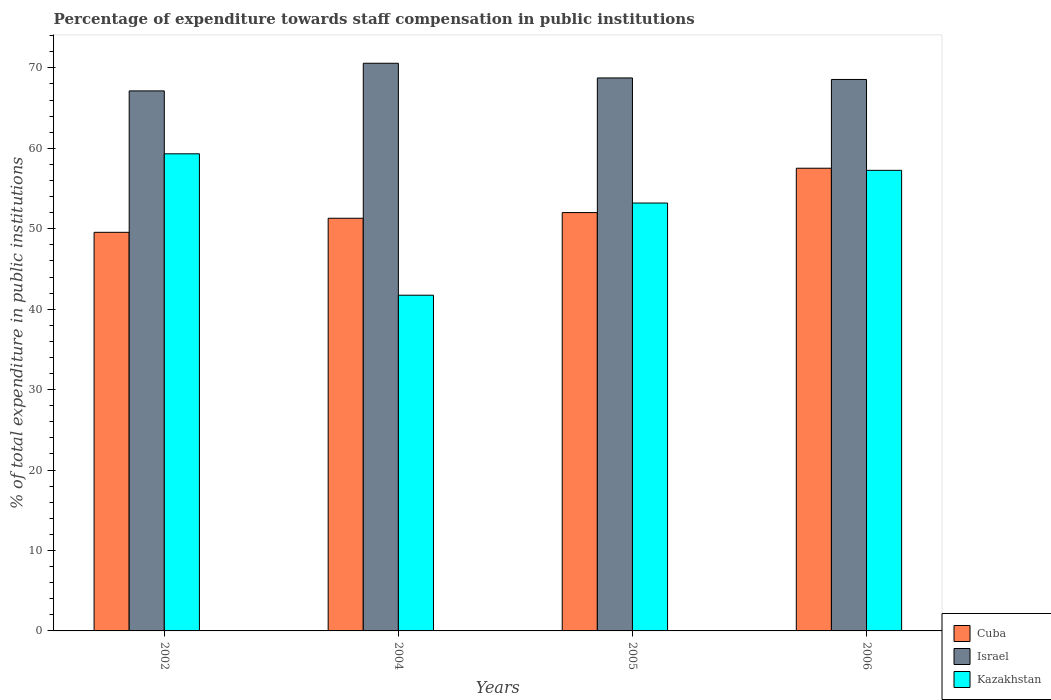How many groups of bars are there?
Ensure brevity in your answer.  4. Are the number of bars on each tick of the X-axis equal?
Your answer should be compact. Yes. How many bars are there on the 3rd tick from the left?
Provide a short and direct response. 3. How many bars are there on the 1st tick from the right?
Give a very brief answer. 3. What is the percentage of expenditure towards staff compensation in Cuba in 2005?
Provide a succinct answer. 52.01. Across all years, what is the maximum percentage of expenditure towards staff compensation in Cuba?
Your answer should be very brief. 57.53. Across all years, what is the minimum percentage of expenditure towards staff compensation in Cuba?
Keep it short and to the point. 49.56. In which year was the percentage of expenditure towards staff compensation in Cuba minimum?
Your answer should be compact. 2002. What is the total percentage of expenditure towards staff compensation in Kazakhstan in the graph?
Provide a succinct answer. 211.52. What is the difference between the percentage of expenditure towards staff compensation in Israel in 2002 and that in 2006?
Offer a very short reply. -1.42. What is the difference between the percentage of expenditure towards staff compensation in Israel in 2005 and the percentage of expenditure towards staff compensation in Cuba in 2004?
Your answer should be very brief. 17.44. What is the average percentage of expenditure towards staff compensation in Kazakhstan per year?
Make the answer very short. 52.88. In the year 2002, what is the difference between the percentage of expenditure towards staff compensation in Kazakhstan and percentage of expenditure towards staff compensation in Israel?
Offer a terse response. -7.82. What is the ratio of the percentage of expenditure towards staff compensation in Israel in 2002 to that in 2004?
Your answer should be very brief. 0.95. Is the percentage of expenditure towards staff compensation in Cuba in 2002 less than that in 2004?
Your response must be concise. Yes. Is the difference between the percentage of expenditure towards staff compensation in Kazakhstan in 2004 and 2005 greater than the difference between the percentage of expenditure towards staff compensation in Israel in 2004 and 2005?
Your response must be concise. No. What is the difference between the highest and the second highest percentage of expenditure towards staff compensation in Cuba?
Ensure brevity in your answer.  5.51. What is the difference between the highest and the lowest percentage of expenditure towards staff compensation in Kazakhstan?
Provide a short and direct response. 17.58. Is the sum of the percentage of expenditure towards staff compensation in Israel in 2004 and 2006 greater than the maximum percentage of expenditure towards staff compensation in Cuba across all years?
Provide a short and direct response. Yes. Is it the case that in every year, the sum of the percentage of expenditure towards staff compensation in Israel and percentage of expenditure towards staff compensation in Cuba is greater than the percentage of expenditure towards staff compensation in Kazakhstan?
Make the answer very short. Yes. How many years are there in the graph?
Keep it short and to the point. 4. Are the values on the major ticks of Y-axis written in scientific E-notation?
Ensure brevity in your answer.  No. Does the graph contain grids?
Offer a very short reply. No. Where does the legend appear in the graph?
Your response must be concise. Bottom right. How are the legend labels stacked?
Provide a short and direct response. Vertical. What is the title of the graph?
Provide a succinct answer. Percentage of expenditure towards staff compensation in public institutions. Does "Latin America(developing only)" appear as one of the legend labels in the graph?
Provide a succinct answer. No. What is the label or title of the X-axis?
Keep it short and to the point. Years. What is the label or title of the Y-axis?
Give a very brief answer. % of total expenditure in public institutions. What is the % of total expenditure in public institutions in Cuba in 2002?
Your answer should be very brief. 49.56. What is the % of total expenditure in public institutions in Israel in 2002?
Make the answer very short. 67.14. What is the % of total expenditure in public institutions in Kazakhstan in 2002?
Keep it short and to the point. 59.32. What is the % of total expenditure in public institutions in Cuba in 2004?
Give a very brief answer. 51.31. What is the % of total expenditure in public institutions in Israel in 2004?
Offer a terse response. 70.58. What is the % of total expenditure in public institutions of Kazakhstan in 2004?
Your answer should be very brief. 41.74. What is the % of total expenditure in public institutions in Cuba in 2005?
Your answer should be very brief. 52.01. What is the % of total expenditure in public institutions of Israel in 2005?
Keep it short and to the point. 68.75. What is the % of total expenditure in public institutions in Kazakhstan in 2005?
Offer a very short reply. 53.2. What is the % of total expenditure in public institutions of Cuba in 2006?
Provide a succinct answer. 57.53. What is the % of total expenditure in public institutions of Israel in 2006?
Offer a terse response. 68.56. What is the % of total expenditure in public institutions in Kazakhstan in 2006?
Your answer should be compact. 57.27. Across all years, what is the maximum % of total expenditure in public institutions in Cuba?
Provide a succinct answer. 57.53. Across all years, what is the maximum % of total expenditure in public institutions in Israel?
Provide a succinct answer. 70.58. Across all years, what is the maximum % of total expenditure in public institutions in Kazakhstan?
Offer a very short reply. 59.32. Across all years, what is the minimum % of total expenditure in public institutions in Cuba?
Provide a short and direct response. 49.56. Across all years, what is the minimum % of total expenditure in public institutions in Israel?
Your answer should be compact. 67.14. Across all years, what is the minimum % of total expenditure in public institutions in Kazakhstan?
Make the answer very short. 41.74. What is the total % of total expenditure in public institutions in Cuba in the graph?
Your answer should be very brief. 210.4. What is the total % of total expenditure in public institutions of Israel in the graph?
Your response must be concise. 275.03. What is the total % of total expenditure in public institutions in Kazakhstan in the graph?
Offer a terse response. 211.52. What is the difference between the % of total expenditure in public institutions in Cuba in 2002 and that in 2004?
Provide a short and direct response. -1.75. What is the difference between the % of total expenditure in public institutions of Israel in 2002 and that in 2004?
Make the answer very short. -3.44. What is the difference between the % of total expenditure in public institutions in Kazakhstan in 2002 and that in 2004?
Provide a short and direct response. 17.58. What is the difference between the % of total expenditure in public institutions in Cuba in 2002 and that in 2005?
Your response must be concise. -2.46. What is the difference between the % of total expenditure in public institutions in Israel in 2002 and that in 2005?
Provide a succinct answer. -1.61. What is the difference between the % of total expenditure in public institutions of Kazakhstan in 2002 and that in 2005?
Offer a very short reply. 6.12. What is the difference between the % of total expenditure in public institutions of Cuba in 2002 and that in 2006?
Offer a very short reply. -7.97. What is the difference between the % of total expenditure in public institutions in Israel in 2002 and that in 2006?
Your response must be concise. -1.42. What is the difference between the % of total expenditure in public institutions in Kazakhstan in 2002 and that in 2006?
Your answer should be compact. 2.05. What is the difference between the % of total expenditure in public institutions of Cuba in 2004 and that in 2005?
Give a very brief answer. -0.71. What is the difference between the % of total expenditure in public institutions of Israel in 2004 and that in 2005?
Provide a succinct answer. 1.83. What is the difference between the % of total expenditure in public institutions in Kazakhstan in 2004 and that in 2005?
Your response must be concise. -11.46. What is the difference between the % of total expenditure in public institutions in Cuba in 2004 and that in 2006?
Make the answer very short. -6.22. What is the difference between the % of total expenditure in public institutions in Israel in 2004 and that in 2006?
Provide a succinct answer. 2.02. What is the difference between the % of total expenditure in public institutions in Kazakhstan in 2004 and that in 2006?
Provide a succinct answer. -15.53. What is the difference between the % of total expenditure in public institutions of Cuba in 2005 and that in 2006?
Provide a succinct answer. -5.51. What is the difference between the % of total expenditure in public institutions in Israel in 2005 and that in 2006?
Offer a very short reply. 0.19. What is the difference between the % of total expenditure in public institutions of Kazakhstan in 2005 and that in 2006?
Offer a very short reply. -4.07. What is the difference between the % of total expenditure in public institutions in Cuba in 2002 and the % of total expenditure in public institutions in Israel in 2004?
Provide a succinct answer. -21.02. What is the difference between the % of total expenditure in public institutions in Cuba in 2002 and the % of total expenditure in public institutions in Kazakhstan in 2004?
Offer a terse response. 7.82. What is the difference between the % of total expenditure in public institutions in Israel in 2002 and the % of total expenditure in public institutions in Kazakhstan in 2004?
Provide a short and direct response. 25.4. What is the difference between the % of total expenditure in public institutions of Cuba in 2002 and the % of total expenditure in public institutions of Israel in 2005?
Make the answer very short. -19.19. What is the difference between the % of total expenditure in public institutions in Cuba in 2002 and the % of total expenditure in public institutions in Kazakhstan in 2005?
Your answer should be compact. -3.64. What is the difference between the % of total expenditure in public institutions in Israel in 2002 and the % of total expenditure in public institutions in Kazakhstan in 2005?
Provide a succinct answer. 13.94. What is the difference between the % of total expenditure in public institutions of Cuba in 2002 and the % of total expenditure in public institutions of Israel in 2006?
Keep it short and to the point. -19.01. What is the difference between the % of total expenditure in public institutions of Cuba in 2002 and the % of total expenditure in public institutions of Kazakhstan in 2006?
Give a very brief answer. -7.71. What is the difference between the % of total expenditure in public institutions of Israel in 2002 and the % of total expenditure in public institutions of Kazakhstan in 2006?
Ensure brevity in your answer.  9.87. What is the difference between the % of total expenditure in public institutions in Cuba in 2004 and the % of total expenditure in public institutions in Israel in 2005?
Keep it short and to the point. -17.44. What is the difference between the % of total expenditure in public institutions of Cuba in 2004 and the % of total expenditure in public institutions of Kazakhstan in 2005?
Keep it short and to the point. -1.89. What is the difference between the % of total expenditure in public institutions of Israel in 2004 and the % of total expenditure in public institutions of Kazakhstan in 2005?
Give a very brief answer. 17.38. What is the difference between the % of total expenditure in public institutions of Cuba in 2004 and the % of total expenditure in public institutions of Israel in 2006?
Provide a short and direct response. -17.25. What is the difference between the % of total expenditure in public institutions in Cuba in 2004 and the % of total expenditure in public institutions in Kazakhstan in 2006?
Provide a succinct answer. -5.96. What is the difference between the % of total expenditure in public institutions of Israel in 2004 and the % of total expenditure in public institutions of Kazakhstan in 2006?
Ensure brevity in your answer.  13.31. What is the difference between the % of total expenditure in public institutions in Cuba in 2005 and the % of total expenditure in public institutions in Israel in 2006?
Ensure brevity in your answer.  -16.55. What is the difference between the % of total expenditure in public institutions in Cuba in 2005 and the % of total expenditure in public institutions in Kazakhstan in 2006?
Make the answer very short. -5.25. What is the difference between the % of total expenditure in public institutions in Israel in 2005 and the % of total expenditure in public institutions in Kazakhstan in 2006?
Give a very brief answer. 11.49. What is the average % of total expenditure in public institutions of Cuba per year?
Make the answer very short. 52.6. What is the average % of total expenditure in public institutions of Israel per year?
Offer a terse response. 68.76. What is the average % of total expenditure in public institutions of Kazakhstan per year?
Provide a succinct answer. 52.88. In the year 2002, what is the difference between the % of total expenditure in public institutions in Cuba and % of total expenditure in public institutions in Israel?
Your response must be concise. -17.58. In the year 2002, what is the difference between the % of total expenditure in public institutions in Cuba and % of total expenditure in public institutions in Kazakhstan?
Your answer should be very brief. -9.76. In the year 2002, what is the difference between the % of total expenditure in public institutions of Israel and % of total expenditure in public institutions of Kazakhstan?
Offer a terse response. 7.82. In the year 2004, what is the difference between the % of total expenditure in public institutions of Cuba and % of total expenditure in public institutions of Israel?
Your answer should be compact. -19.27. In the year 2004, what is the difference between the % of total expenditure in public institutions of Cuba and % of total expenditure in public institutions of Kazakhstan?
Provide a succinct answer. 9.57. In the year 2004, what is the difference between the % of total expenditure in public institutions in Israel and % of total expenditure in public institutions in Kazakhstan?
Ensure brevity in your answer.  28.84. In the year 2005, what is the difference between the % of total expenditure in public institutions in Cuba and % of total expenditure in public institutions in Israel?
Offer a very short reply. -16.74. In the year 2005, what is the difference between the % of total expenditure in public institutions in Cuba and % of total expenditure in public institutions in Kazakhstan?
Provide a succinct answer. -1.19. In the year 2005, what is the difference between the % of total expenditure in public institutions in Israel and % of total expenditure in public institutions in Kazakhstan?
Keep it short and to the point. 15.55. In the year 2006, what is the difference between the % of total expenditure in public institutions of Cuba and % of total expenditure in public institutions of Israel?
Give a very brief answer. -11.03. In the year 2006, what is the difference between the % of total expenditure in public institutions of Cuba and % of total expenditure in public institutions of Kazakhstan?
Your answer should be very brief. 0.26. In the year 2006, what is the difference between the % of total expenditure in public institutions of Israel and % of total expenditure in public institutions of Kazakhstan?
Give a very brief answer. 11.3. What is the ratio of the % of total expenditure in public institutions of Cuba in 2002 to that in 2004?
Offer a very short reply. 0.97. What is the ratio of the % of total expenditure in public institutions of Israel in 2002 to that in 2004?
Give a very brief answer. 0.95. What is the ratio of the % of total expenditure in public institutions in Kazakhstan in 2002 to that in 2004?
Provide a succinct answer. 1.42. What is the ratio of the % of total expenditure in public institutions in Cuba in 2002 to that in 2005?
Your answer should be very brief. 0.95. What is the ratio of the % of total expenditure in public institutions in Israel in 2002 to that in 2005?
Your answer should be compact. 0.98. What is the ratio of the % of total expenditure in public institutions of Kazakhstan in 2002 to that in 2005?
Provide a short and direct response. 1.11. What is the ratio of the % of total expenditure in public institutions of Cuba in 2002 to that in 2006?
Keep it short and to the point. 0.86. What is the ratio of the % of total expenditure in public institutions in Israel in 2002 to that in 2006?
Offer a terse response. 0.98. What is the ratio of the % of total expenditure in public institutions of Kazakhstan in 2002 to that in 2006?
Provide a short and direct response. 1.04. What is the ratio of the % of total expenditure in public institutions in Cuba in 2004 to that in 2005?
Your answer should be very brief. 0.99. What is the ratio of the % of total expenditure in public institutions of Israel in 2004 to that in 2005?
Your response must be concise. 1.03. What is the ratio of the % of total expenditure in public institutions of Kazakhstan in 2004 to that in 2005?
Give a very brief answer. 0.78. What is the ratio of the % of total expenditure in public institutions in Cuba in 2004 to that in 2006?
Provide a succinct answer. 0.89. What is the ratio of the % of total expenditure in public institutions of Israel in 2004 to that in 2006?
Keep it short and to the point. 1.03. What is the ratio of the % of total expenditure in public institutions of Kazakhstan in 2004 to that in 2006?
Keep it short and to the point. 0.73. What is the ratio of the % of total expenditure in public institutions of Cuba in 2005 to that in 2006?
Ensure brevity in your answer.  0.9. What is the ratio of the % of total expenditure in public institutions of Kazakhstan in 2005 to that in 2006?
Offer a terse response. 0.93. What is the difference between the highest and the second highest % of total expenditure in public institutions of Cuba?
Provide a succinct answer. 5.51. What is the difference between the highest and the second highest % of total expenditure in public institutions in Israel?
Offer a very short reply. 1.83. What is the difference between the highest and the second highest % of total expenditure in public institutions of Kazakhstan?
Your answer should be very brief. 2.05. What is the difference between the highest and the lowest % of total expenditure in public institutions of Cuba?
Ensure brevity in your answer.  7.97. What is the difference between the highest and the lowest % of total expenditure in public institutions in Israel?
Ensure brevity in your answer.  3.44. What is the difference between the highest and the lowest % of total expenditure in public institutions of Kazakhstan?
Keep it short and to the point. 17.58. 